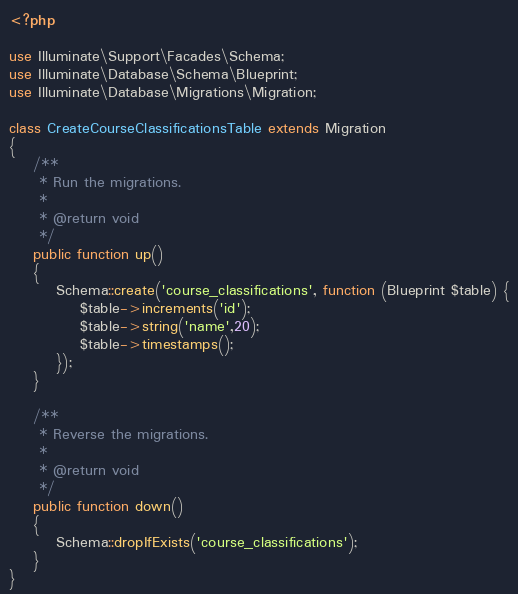Convert code to text. <code><loc_0><loc_0><loc_500><loc_500><_PHP_><?php

use Illuminate\Support\Facades\Schema;
use Illuminate\Database\Schema\Blueprint;
use Illuminate\Database\Migrations\Migration;

class CreateCourseClassificationsTable extends Migration
{
    /**
     * Run the migrations.
     *
     * @return void
     */
    public function up()
    {
        Schema::create('course_classifications', function (Blueprint $table) {
            $table->increments('id');
            $table->string('name',20);
            $table->timestamps();
        });
    }

    /**
     * Reverse the migrations.
     *
     * @return void
     */
    public function down()
    {
        Schema::dropIfExists('course_classifications');
    }
}
</code> 